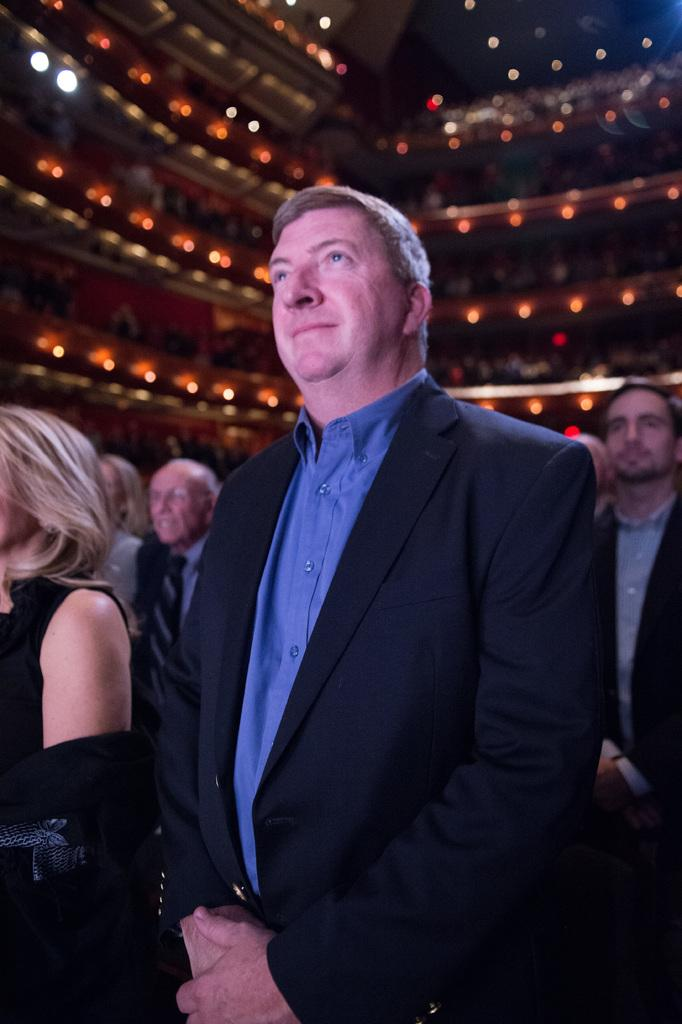What is happening in the image? There are people standing in the image. What can be seen in the distance behind the people? There is a building in the background of the image. Are there any additional features visible in the image? Yes, there are lights visible in the image. How many crows are sitting on the woman's head in the image? There is no woman or crow present in the image. 